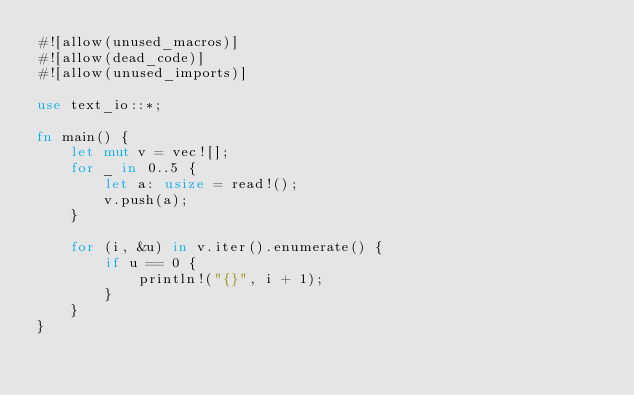<code> <loc_0><loc_0><loc_500><loc_500><_Rust_>#![allow(unused_macros)]
#![allow(dead_code)]
#![allow(unused_imports)]

use text_io::*;

fn main() {
    let mut v = vec![];
    for _ in 0..5 {
        let a: usize = read!();
        v.push(a);
    }

    for (i, &u) in v.iter().enumerate() {
        if u == 0 {
            println!("{}", i + 1);
        }
    }
}
</code> 